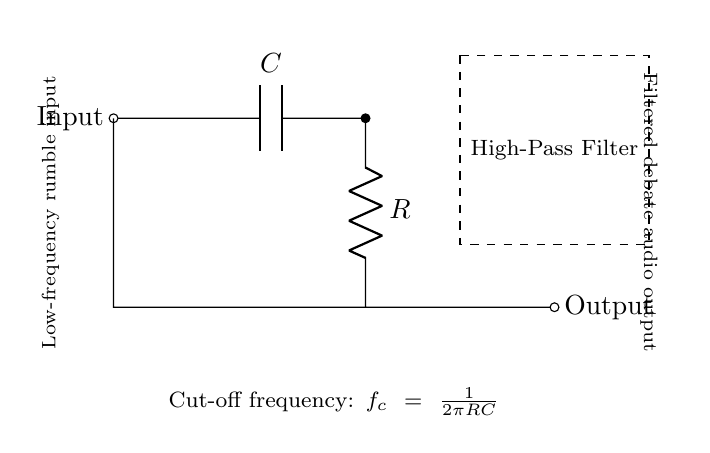What is the input to the circuit? The input is labeled as "Input" on the left side of the diagram, indicating the signal that enters the high-pass filter.
Answer: Input What components are used in this high-pass filter? The circuit diagram shows a capacitor and a resistor connected in series, which are the basic components of the high-pass filter.
Answer: Capacitor and resistor What is the purpose of the dashed rectangle in the diagram? The dashed rectangle encloses the components of the high-pass filter, visually defining the boundaries of the filter section in the circuit.
Answer: To indicate the high-pass filter What is the function of the capacitor in this filter? The capacitor blocks low-frequency signals while allowing higher frequency signals to pass through, which is essential for filtering out rumble.
Answer: Blocks low frequencies What does "cut-off frequency" refer to in this context? The cut-off frequency is the frequency at which the output voltage is reduced to 70.7% of the input voltage, calculated using the formula provided in the diagram.
Answer: Frequency at 70.7% output How is the cut-off frequency calculated? The cut-off frequency is calculated using the formula f_c equals one divided by two pi times R times C, as stated in the diagram.
Answer: One divided by two pi R C 